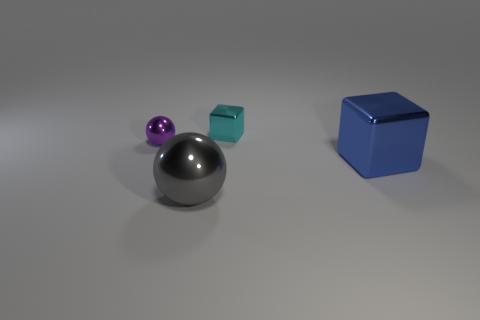Subtract 1 spheres. How many spheres are left? 1 Subtract all blue balls. Subtract all purple blocks. How many balls are left? 2 Add 2 spheres. How many objects exist? 6 Add 3 blue metal blocks. How many blue metal blocks exist? 4 Subtract 0 cyan balls. How many objects are left? 4 Subtract all red matte objects. Subtract all large metal spheres. How many objects are left? 3 Add 4 small purple metal things. How many small purple metal things are left? 5 